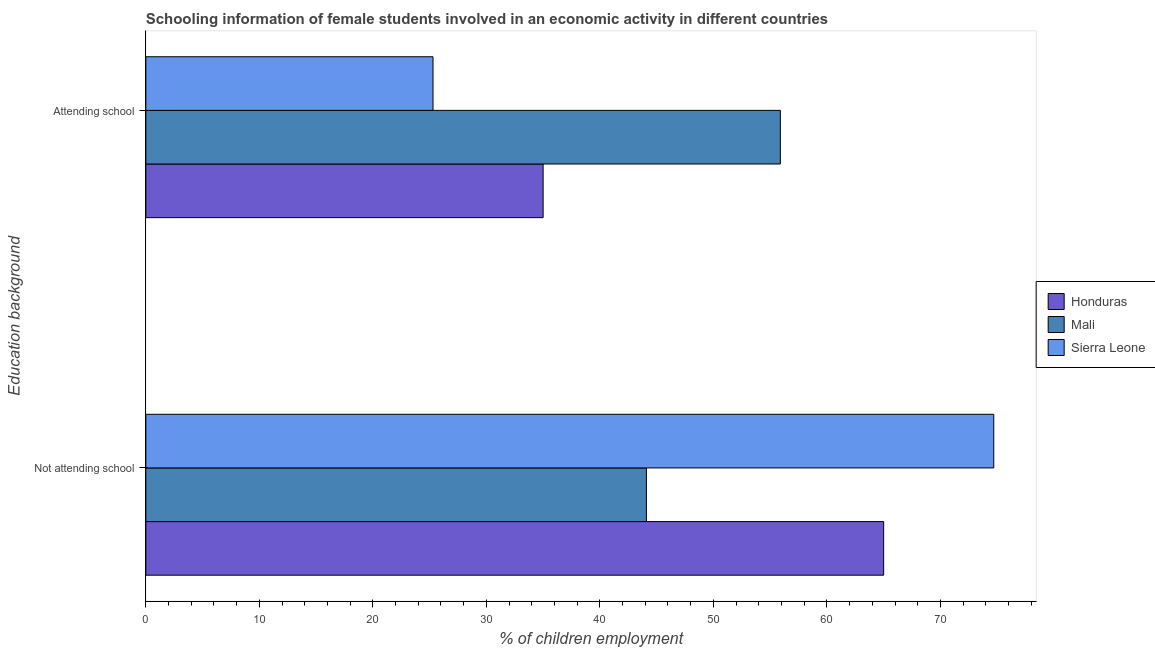How many groups of bars are there?
Give a very brief answer. 2. Are the number of bars per tick equal to the number of legend labels?
Offer a terse response. Yes. What is the label of the 1st group of bars from the top?
Your answer should be very brief. Attending school. What is the percentage of employed females who are not attending school in Honduras?
Your response must be concise. 65. Across all countries, what is the maximum percentage of employed females who are attending school?
Offer a very short reply. 55.9. Across all countries, what is the minimum percentage of employed females who are attending school?
Offer a very short reply. 25.3. In which country was the percentage of employed females who are not attending school maximum?
Keep it short and to the point. Sierra Leone. In which country was the percentage of employed females who are attending school minimum?
Your answer should be compact. Sierra Leone. What is the total percentage of employed females who are attending school in the graph?
Your response must be concise. 116.2. What is the difference between the percentage of employed females who are attending school in Mali and that in Sierra Leone?
Offer a very short reply. 30.6. What is the difference between the percentage of employed females who are not attending school in Sierra Leone and the percentage of employed females who are attending school in Mali?
Keep it short and to the point. 18.8. What is the average percentage of employed females who are attending school per country?
Offer a very short reply. 38.73. What is the difference between the percentage of employed females who are not attending school and percentage of employed females who are attending school in Sierra Leone?
Offer a terse response. 49.4. What is the ratio of the percentage of employed females who are not attending school in Mali to that in Honduras?
Provide a short and direct response. 0.68. Is the percentage of employed females who are attending school in Mali less than that in Sierra Leone?
Your response must be concise. No. In how many countries, is the percentage of employed females who are not attending school greater than the average percentage of employed females who are not attending school taken over all countries?
Your answer should be very brief. 2. What does the 1st bar from the top in Attending school represents?
Offer a very short reply. Sierra Leone. What does the 1st bar from the bottom in Attending school represents?
Your answer should be very brief. Honduras. How many bars are there?
Your answer should be compact. 6. Are all the bars in the graph horizontal?
Your response must be concise. Yes. What is the difference between two consecutive major ticks on the X-axis?
Offer a terse response. 10. Does the graph contain any zero values?
Keep it short and to the point. No. How are the legend labels stacked?
Offer a terse response. Vertical. What is the title of the graph?
Offer a very short reply. Schooling information of female students involved in an economic activity in different countries. Does "Sweden" appear as one of the legend labels in the graph?
Make the answer very short. No. What is the label or title of the X-axis?
Offer a terse response. % of children employment. What is the label or title of the Y-axis?
Your response must be concise. Education background. What is the % of children employment in Honduras in Not attending school?
Provide a short and direct response. 65. What is the % of children employment of Mali in Not attending school?
Keep it short and to the point. 44.1. What is the % of children employment in Sierra Leone in Not attending school?
Provide a short and direct response. 74.7. What is the % of children employment in Honduras in Attending school?
Provide a short and direct response. 35. What is the % of children employment of Mali in Attending school?
Give a very brief answer. 55.9. What is the % of children employment in Sierra Leone in Attending school?
Offer a terse response. 25.3. Across all Education background, what is the maximum % of children employment of Honduras?
Provide a short and direct response. 65. Across all Education background, what is the maximum % of children employment of Mali?
Your answer should be very brief. 55.9. Across all Education background, what is the maximum % of children employment in Sierra Leone?
Your answer should be compact. 74.7. Across all Education background, what is the minimum % of children employment in Honduras?
Your answer should be very brief. 35. Across all Education background, what is the minimum % of children employment in Mali?
Give a very brief answer. 44.1. Across all Education background, what is the minimum % of children employment in Sierra Leone?
Provide a short and direct response. 25.3. What is the total % of children employment of Honduras in the graph?
Provide a succinct answer. 100. What is the total % of children employment in Mali in the graph?
Make the answer very short. 100. What is the total % of children employment of Sierra Leone in the graph?
Make the answer very short. 100. What is the difference between the % of children employment of Honduras in Not attending school and that in Attending school?
Make the answer very short. 30. What is the difference between the % of children employment in Sierra Leone in Not attending school and that in Attending school?
Provide a short and direct response. 49.4. What is the difference between the % of children employment of Honduras in Not attending school and the % of children employment of Sierra Leone in Attending school?
Give a very brief answer. 39.7. What is the average % of children employment of Honduras per Education background?
Your answer should be very brief. 50. What is the average % of children employment in Mali per Education background?
Offer a terse response. 50. What is the average % of children employment in Sierra Leone per Education background?
Your answer should be compact. 50. What is the difference between the % of children employment in Honduras and % of children employment in Mali in Not attending school?
Offer a very short reply. 20.9. What is the difference between the % of children employment of Honduras and % of children employment of Sierra Leone in Not attending school?
Offer a terse response. -9.7. What is the difference between the % of children employment in Mali and % of children employment in Sierra Leone in Not attending school?
Offer a very short reply. -30.6. What is the difference between the % of children employment in Honduras and % of children employment in Mali in Attending school?
Offer a very short reply. -20.9. What is the difference between the % of children employment in Honduras and % of children employment in Sierra Leone in Attending school?
Your answer should be very brief. 9.7. What is the difference between the % of children employment in Mali and % of children employment in Sierra Leone in Attending school?
Your response must be concise. 30.6. What is the ratio of the % of children employment of Honduras in Not attending school to that in Attending school?
Provide a short and direct response. 1.86. What is the ratio of the % of children employment of Mali in Not attending school to that in Attending school?
Your response must be concise. 0.79. What is the ratio of the % of children employment in Sierra Leone in Not attending school to that in Attending school?
Provide a short and direct response. 2.95. What is the difference between the highest and the second highest % of children employment in Mali?
Offer a very short reply. 11.8. What is the difference between the highest and the second highest % of children employment in Sierra Leone?
Your answer should be very brief. 49.4. What is the difference between the highest and the lowest % of children employment in Sierra Leone?
Keep it short and to the point. 49.4. 